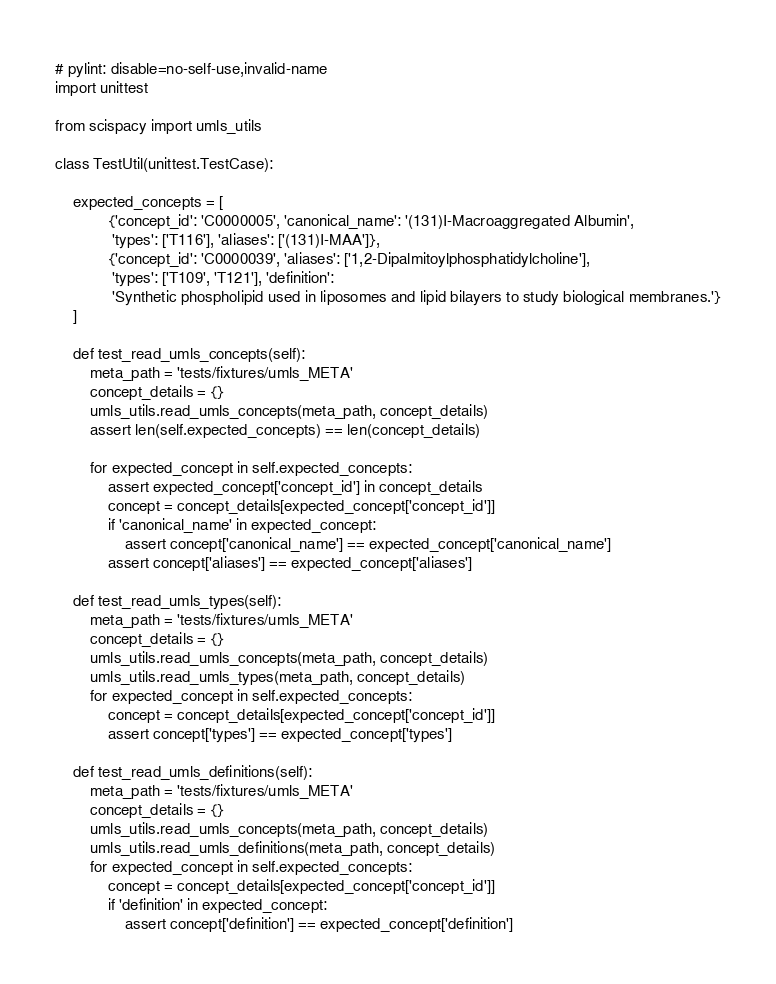Convert code to text. <code><loc_0><loc_0><loc_500><loc_500><_Python_># pylint: disable=no-self-use,invalid-name
import unittest

from scispacy import umls_utils

class TestUtil(unittest.TestCase):

    expected_concepts = [
            {'concept_id': 'C0000005', 'canonical_name': '(131)I-Macroaggregated Albumin',
             'types': ['T116'], 'aliases': ['(131)I-MAA']},
            {'concept_id': 'C0000039', 'aliases': ['1,2-Dipalmitoylphosphatidylcholine'],
             'types': ['T109', 'T121'], 'definition':
             'Synthetic phospholipid used in liposomes and lipid bilayers to study biological membranes.'}
    ]

    def test_read_umls_concepts(self):
        meta_path = 'tests/fixtures/umls_META'
        concept_details = {}
        umls_utils.read_umls_concepts(meta_path, concept_details)
        assert len(self.expected_concepts) == len(concept_details)

        for expected_concept in self.expected_concepts:
            assert expected_concept['concept_id'] in concept_details
            concept = concept_details[expected_concept['concept_id']]
            if 'canonical_name' in expected_concept:
                assert concept['canonical_name'] == expected_concept['canonical_name']
            assert concept['aliases'] == expected_concept['aliases']

    def test_read_umls_types(self):
        meta_path = 'tests/fixtures/umls_META'
        concept_details = {}
        umls_utils.read_umls_concepts(meta_path, concept_details)
        umls_utils.read_umls_types(meta_path, concept_details)
        for expected_concept in self.expected_concepts:
            concept = concept_details[expected_concept['concept_id']]
            assert concept['types'] == expected_concept['types']

    def test_read_umls_definitions(self):
        meta_path = 'tests/fixtures/umls_META'
        concept_details = {}
        umls_utils.read_umls_concepts(meta_path, concept_details)
        umls_utils.read_umls_definitions(meta_path, concept_details)
        for expected_concept in self.expected_concepts:
            concept = concept_details[expected_concept['concept_id']]
            if 'definition' in expected_concept:
                assert concept['definition'] == expected_concept['definition']
</code> 